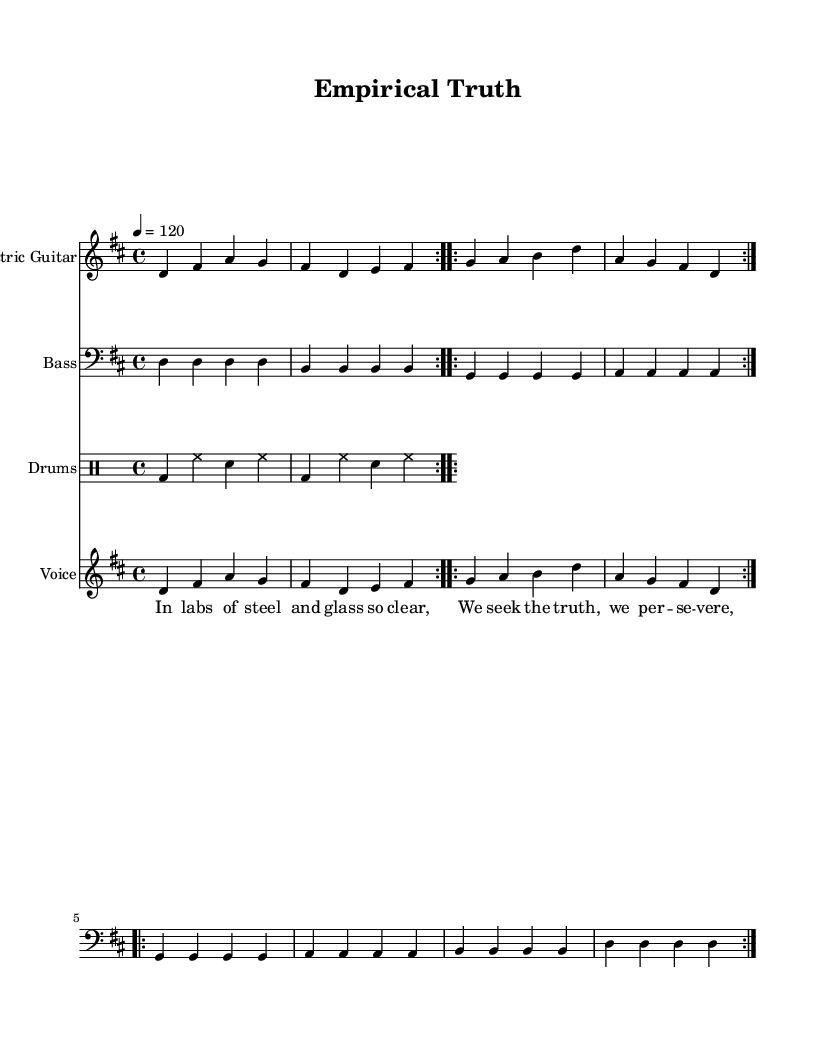What is the key signature of this music? The key signature is indicated at the beginning of the piece with a 'd' which shows that there are two sharps (F# and C#), making it D major.
Answer: D major What is the time signature of this music? The time signature is specified at the beginning with a '4/4', indicating that there are four beats per measure and the quarter note gets the beat.
Answer: 4/4 What is the tempo marking of this music? The tempo is indicated with '4 = 120', which means there are 120 beats per minute. The number '4' corresponds to the quarter note being the note value used for counting the tempo.
Answer: 120 How many times is the verse repeated? The section labeled 'verse' is designed to repeat twice, as indicated by the use of the repeat markings that wrap around the lyrics, suggesting a repetition.
Answer: 2 What instruments are represented in the score? The score contains three parts for different instruments: Electric Guitar, Bass, and Drums. Each part is clearly labeled with the instrument's name at the start of its respective staff.
Answer: Electric Guitar, Bass, Drums What lyrical theme is conveyed in the chorus? The chorus lyrics mention "evidence-based", implying a focus on scientific methods rather than alternative medicine solutions like "snake oil" or "crystal ball", which represents a pro-science stance.
Answer: Evidence-based 